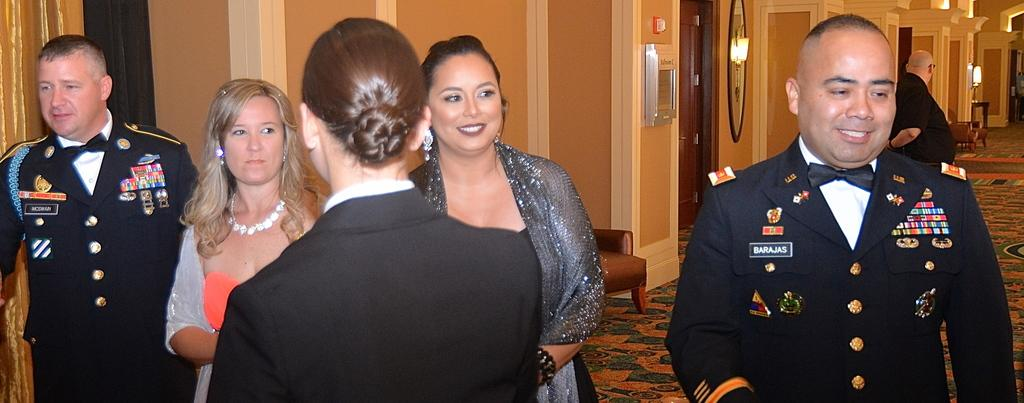What can be observed about the clothing of the people in the image? There are people wearing different color dresses in the image. What is visible in the background of the image? There is light and a chair in the background of the image. How would you describe the color of the wall in the image? The wall is in cream and brown color. Can you hear the robin singing in the image? There is no robin present in the image, so it is not possible to hear it singing. 